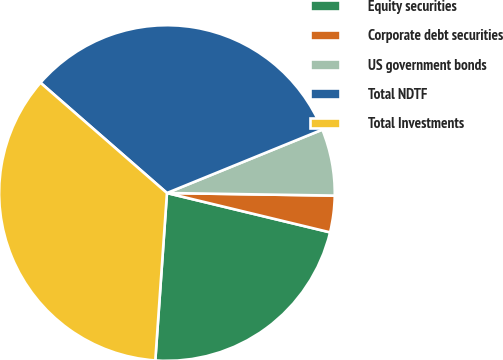Convert chart. <chart><loc_0><loc_0><loc_500><loc_500><pie_chart><fcel>Equity securities<fcel>Corporate debt securities<fcel>US government bonds<fcel>Total NDTF<fcel>Total Investments<nl><fcel>22.34%<fcel>3.52%<fcel>6.41%<fcel>32.42%<fcel>35.31%<nl></chart> 